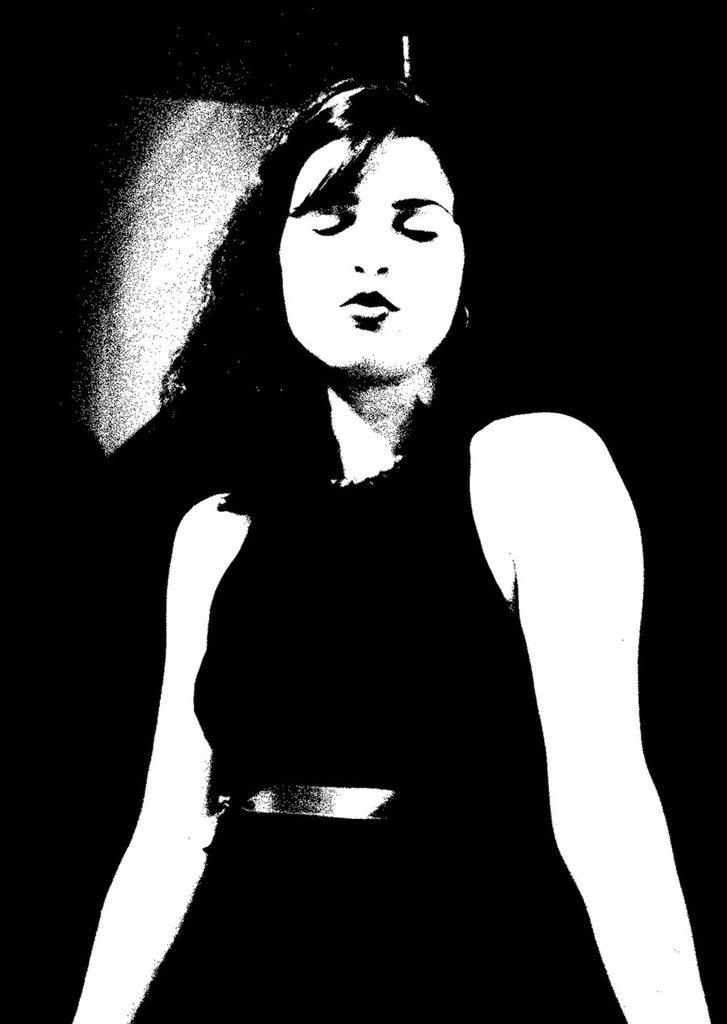Who is the main subject in the image? There is a woman in the image. What can be observed about the background of the image? The background of the image is dark in color. What direction are the trains moving in the image? There are no trains present in the image. 